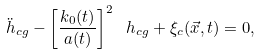<formula> <loc_0><loc_0><loc_500><loc_500>\ddot { h } _ { c g } - \left [ \frac { k _ { 0 } ( t ) } { a ( t ) } \right ] ^ { 2 } \ h _ { c g } + \xi _ { c } ( \vec { x } , t ) = 0 ,</formula> 